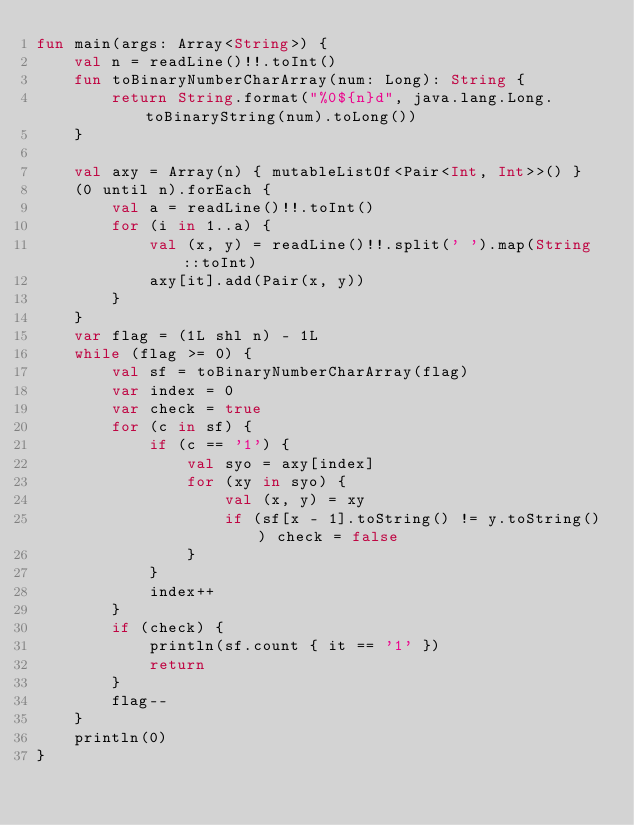Convert code to text. <code><loc_0><loc_0><loc_500><loc_500><_Kotlin_>fun main(args: Array<String>) {
    val n = readLine()!!.toInt()
    fun toBinaryNumberCharArray(num: Long): String {
        return String.format("%0${n}d", java.lang.Long.toBinaryString(num).toLong())
    }

    val axy = Array(n) { mutableListOf<Pair<Int, Int>>() }
    (0 until n).forEach {
        val a = readLine()!!.toInt()
        for (i in 1..a) {
            val (x, y) = readLine()!!.split(' ').map(String::toInt)
            axy[it].add(Pair(x, y))
        }
    }
    var flag = (1L shl n) - 1L
    while (flag >= 0) {
        val sf = toBinaryNumberCharArray(flag)
        var index = 0
        var check = true
        for (c in sf) {
            if (c == '1') {
                val syo = axy[index]
                for (xy in syo) {
                    val (x, y) = xy
                    if (sf[x - 1].toString() != y.toString()) check = false
                }
            }
            index++
        }
        if (check) {
            println(sf.count { it == '1' })
            return
        }
        flag--
    }
    println(0)
}</code> 